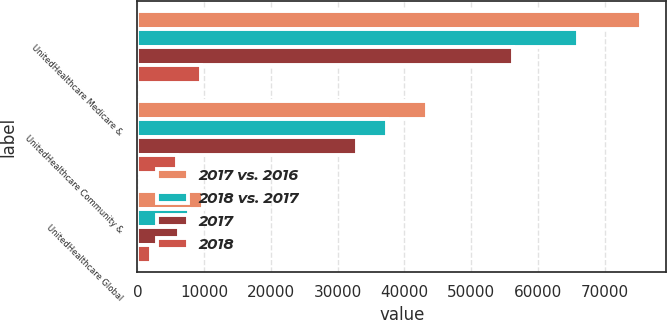<chart> <loc_0><loc_0><loc_500><loc_500><stacked_bar_chart><ecel><fcel>UnitedHealthcare Medicare &<fcel>UnitedHealthcare Community &<fcel>UnitedHealthcare Global<nl><fcel>2017 vs. 2016<fcel>75473<fcel>43426<fcel>9816<nl><fcel>2018 vs. 2017<fcel>65995<fcel>37443<fcel>7753<nl><fcel>2017<fcel>56329<fcel>32945<fcel>6223<nl><fcel>2018<fcel>9478<fcel>5983<fcel>2063<nl></chart> 